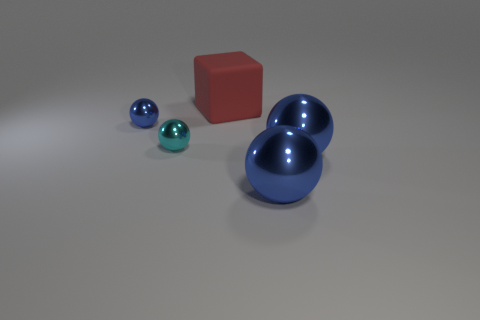What shape is the blue metallic object that is the same size as the cyan sphere?
Ensure brevity in your answer.  Sphere. What number of other things are there of the same shape as the tiny cyan shiny object?
Your answer should be very brief. 3. There is a cyan shiny sphere; is it the same size as the blue metal object that is to the left of the red cube?
Your answer should be very brief. Yes. How many things are blue metal things left of the cyan shiny sphere or small purple matte cubes?
Offer a very short reply. 1. What is the shape of the blue object that is on the left side of the small cyan metallic object?
Offer a very short reply. Sphere. Are there the same number of big red objects that are in front of the cyan metallic sphere and red things in front of the red block?
Make the answer very short. Yes. There is a object that is both behind the small cyan metallic object and on the left side of the red thing; what color is it?
Offer a terse response. Blue. What is the large thing behind the tiny thing right of the tiny blue metal thing made of?
Provide a short and direct response. Rubber. Is the red object the same size as the cyan sphere?
Give a very brief answer. No. What number of large objects are matte things or brown blocks?
Provide a short and direct response. 1. 